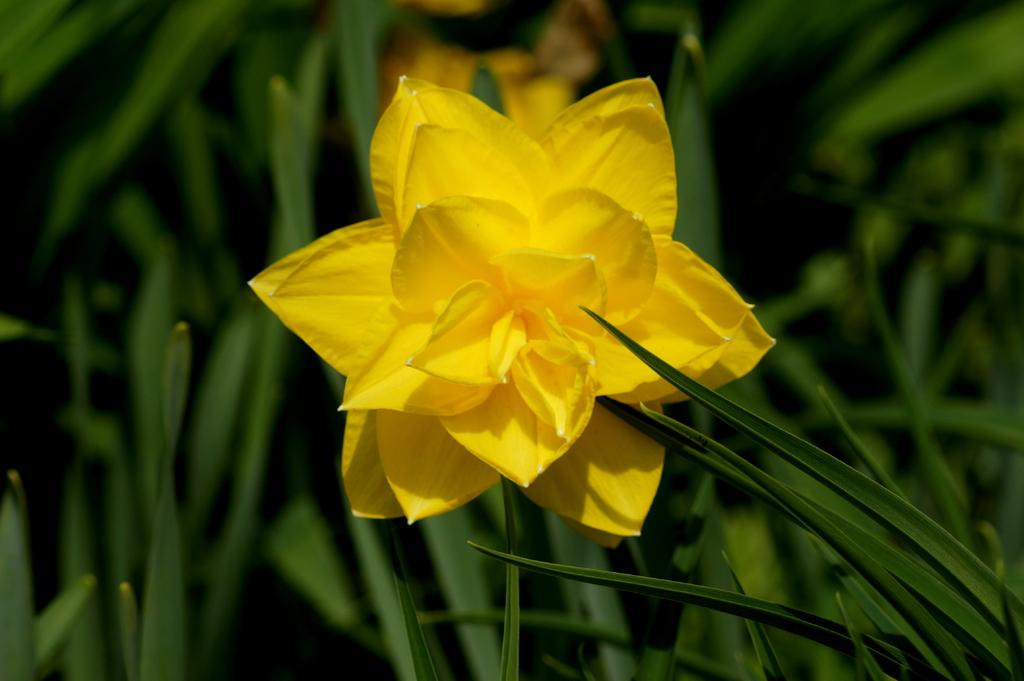What is the main subject in the foreground of the image? There is a yellow flower in the foreground of the image. What is the color of the flower? The flower is yellow. What type of environment surrounds the yellow flower? The yellow flower is surrounded by greenery. Can you see any veins in the yellow flower? There is no mention of veins in the flower, and the image does not provide enough detail to determine if veins are visible. --- 